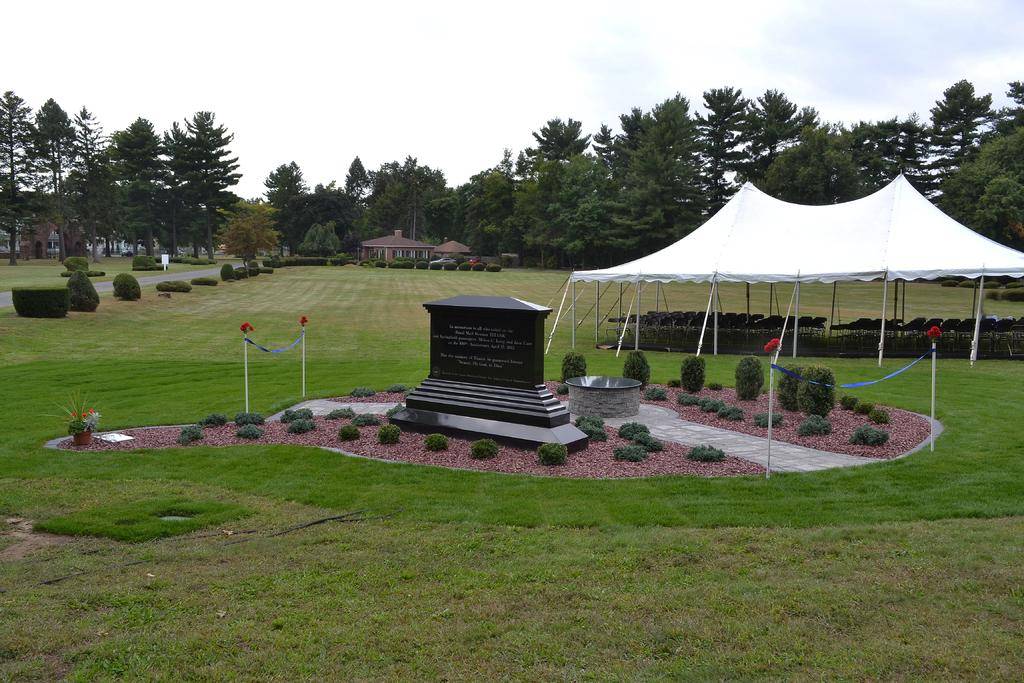What is the main object in the picture? There is a stone in the picture. What type of vegetation can be seen in the picture? There are plants and grass in the picture. What is the color tint of the picture? The picture has a white color tint. What can be seen in the background of the picture? There are houses, trees, and the sky visible in the background of the picture. What is the title of the book the passenger is reading in the picture? There is no passenger or book present in the picture; it features a stone, plants, grass, and a background with houses, trees, and the sky. 